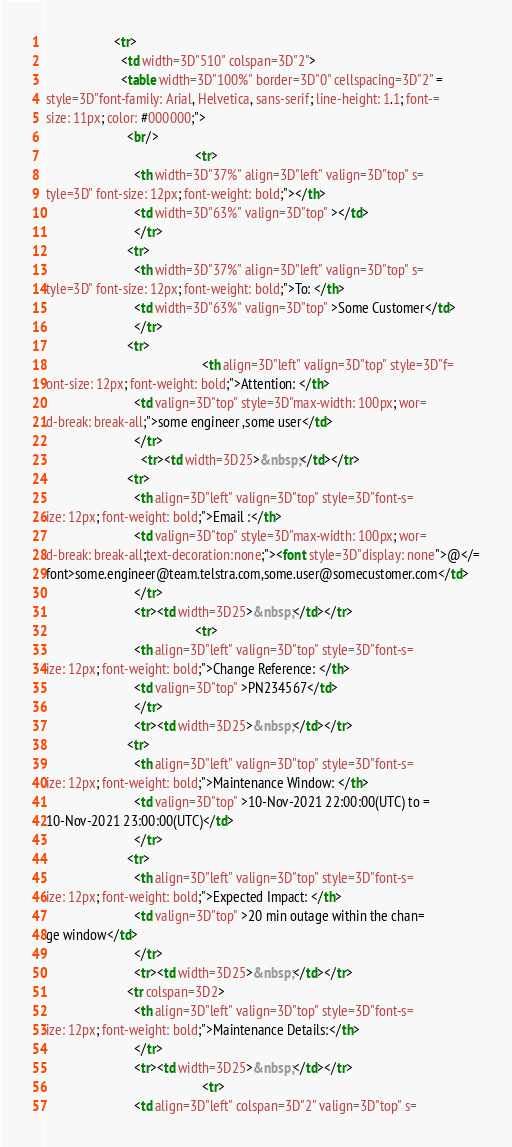<code> <loc_0><loc_0><loc_500><loc_500><_HTML_>                    <tr>
                      <td width=3D"510" colspan=3D"2">
                      <table width=3D"100%" border=3D"0" cellspacing=3D"2" =
style=3D"font-family: Arial, Helvetica, sans-serif; line-height: 1.1; font-=
size: 11px; color: #000000;">
                        <br/>
											<tr>
                          <th width=3D"37%" align=3D"left" valign=3D"top" s=
tyle=3D" font-size: 12px; font-weight: bold;"></th>
                          <td width=3D"63%" valign=3D"top" ></td>
						  </tr>
						<tr>
                          <th width=3D"37%" align=3D"left" valign=3D"top" s=
tyle=3D" font-size: 12px; font-weight: bold;">To: </th>
                          <td width=3D"63%" valign=3D"top" >Some Customer</td>
						  </tr>
						<tr>
					                          <th align=3D"left" valign=3D"top" style=3D"f=
ont-size: 12px; font-weight: bold;">Attention: </th>
                          <td valign=3D"top" style=3D"max-width: 100px; wor=
d-break: break-all;">some engineer ,some user</td>
                          </tr>
							<tr><td width=3D25>&nbsp;</td></tr>
                        <tr>
                          <th align=3D"left" valign=3D"top" style=3D"font-s=
ize: 12px; font-weight: bold;">Email :</th>
                          <td valign=3D"top" style=3D"max-width: 100px; wor=
d-break: break-all;text-decoration:none;"><font style=3D"display: none">@</=
font>some.engineer@team.telstra.com,some.user@somecustomer.com</td>
                          </tr>
						  <tr><td width=3D25>&nbsp;</td></tr>
					                        <tr>
                          <th align=3D"left" valign=3D"top" style=3D"font-s=
ize: 12px; font-weight: bold;">Change Reference: </th>
                          <td valign=3D"top" >PN234567</td>
                          </tr>
						  <tr><td width=3D25>&nbsp;</td></tr>
                        <tr>
                          <th align=3D"left" valign=3D"top" style=3D"font-s=
ize: 12px; font-weight: bold;">Maintenance Window: </th>
                          <td valign=3D"top" >10-Nov-2021 22:00:00(UTC) to =
10-Nov-2021 23:00:00(UTC)</td>
                          </tr>
                        <tr>
                          <th align=3D"left" valign=3D"top" style=3D"font-s=
ize: 12px; font-weight: bold;">Expected Impact: </th>
                          <td valign=3D"top" >20 min outage within the chan=
ge window</td>
                          </tr>
						  <tr><td width=3D25>&nbsp;</td></tr>
                        <tr colspan=3D2>
                          <th align=3D"left" valign=3D"top" style=3D"font-s=
ize: 12px; font-weight: bold;">Maintenance Details:</th>
                          </tr>
						  <tr><td width=3D25>&nbsp;</td></tr>
											  <tr>
                          <td align=3D"left" colspan=3D"2" valign=3D"top" s=</code> 